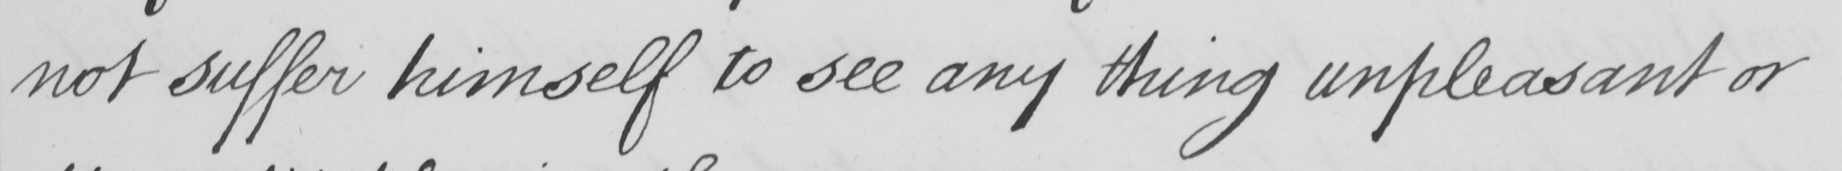What does this handwritten line say? not suffer himself to see any thing unpleasant or 